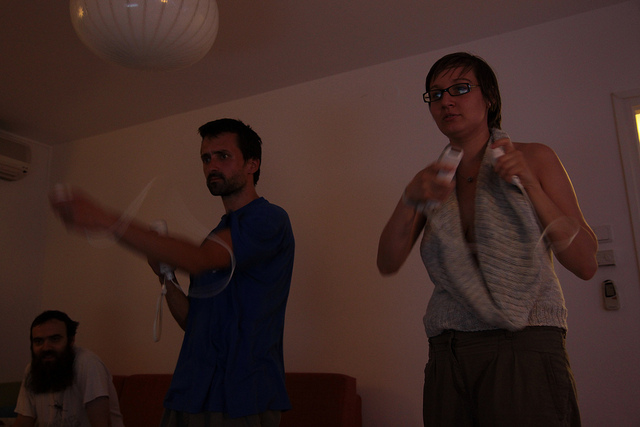<image>Is the sun shining? It is unanswerable whether the sun is shining. Why does he have two phones? The person doesn't have two phones. The objects might be mistaken for Wii remotes or gaming devices. Is the sun shining? No, the sun is not shining. Why does he have two phones? I don't know why he has two phones. It can be for playing Wii or video games. 